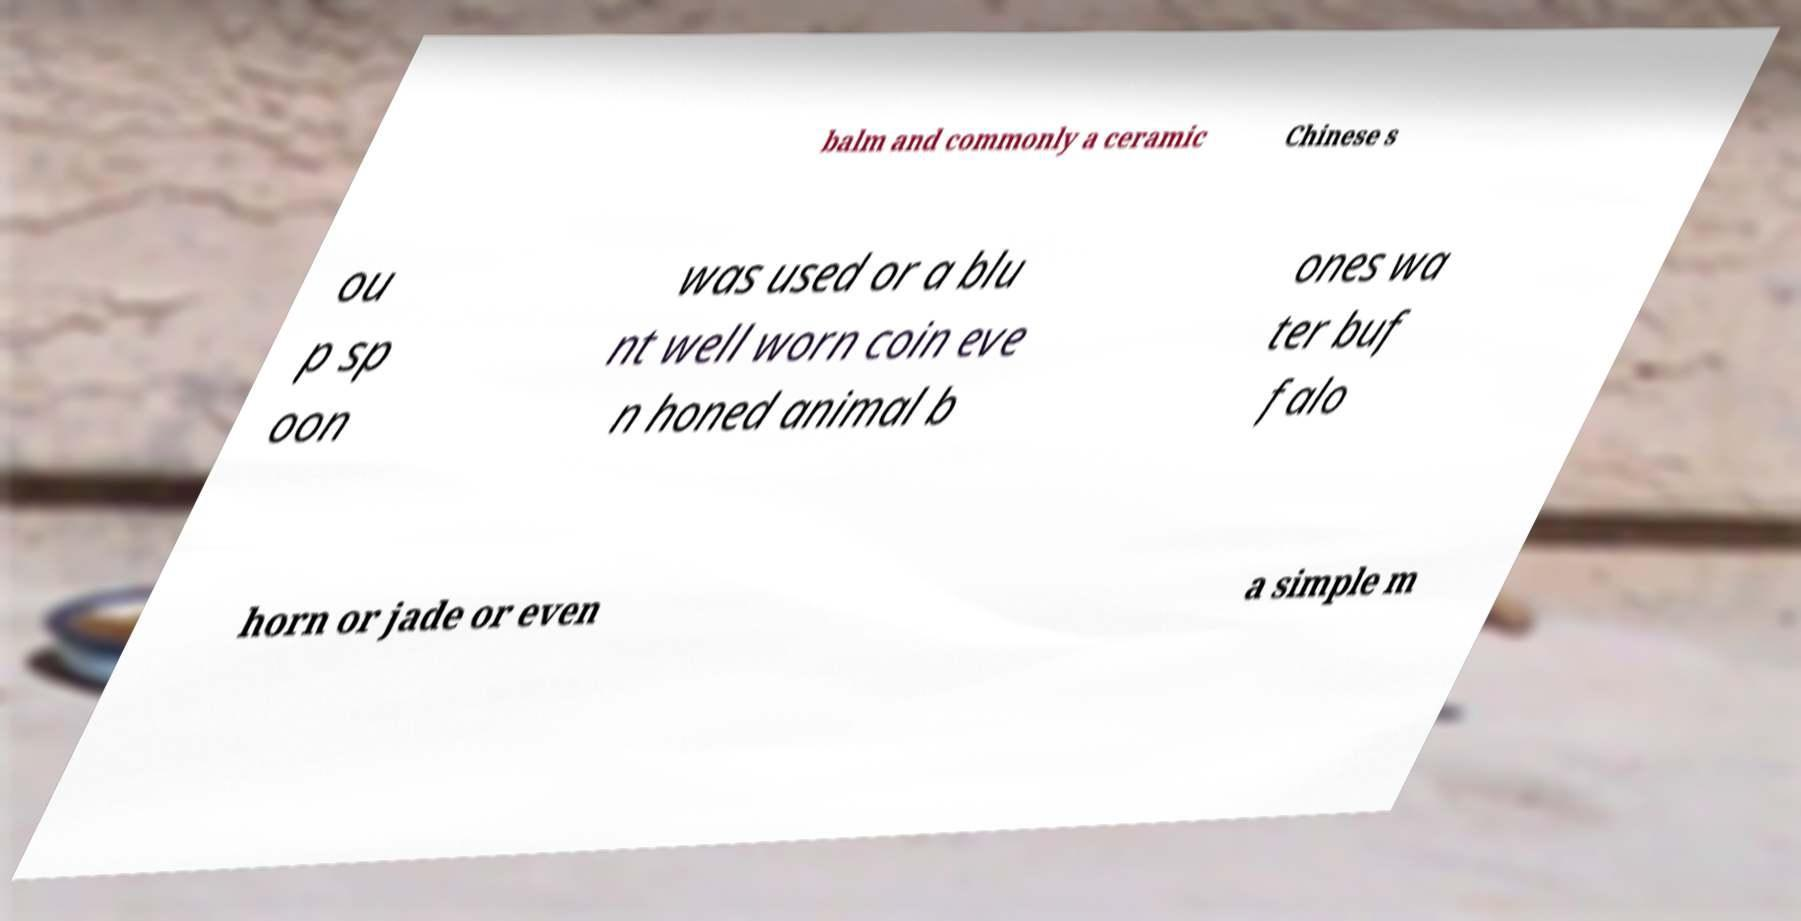Could you assist in decoding the text presented in this image and type it out clearly? balm and commonly a ceramic Chinese s ou p sp oon was used or a blu nt well worn coin eve n honed animal b ones wa ter buf falo horn or jade or even a simple m 